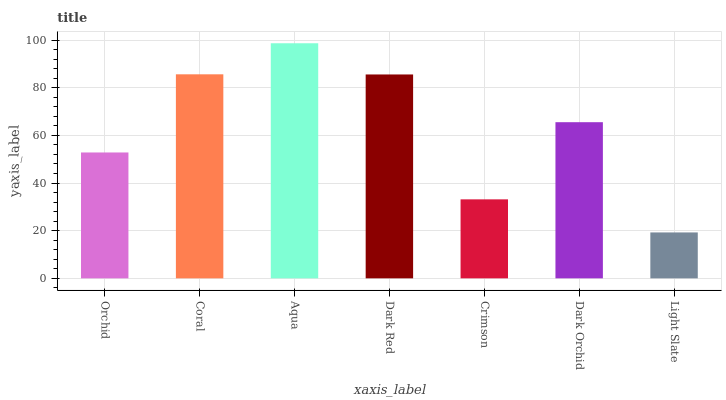Is Light Slate the minimum?
Answer yes or no. Yes. Is Aqua the maximum?
Answer yes or no. Yes. Is Coral the minimum?
Answer yes or no. No. Is Coral the maximum?
Answer yes or no. No. Is Coral greater than Orchid?
Answer yes or no. Yes. Is Orchid less than Coral?
Answer yes or no. Yes. Is Orchid greater than Coral?
Answer yes or no. No. Is Coral less than Orchid?
Answer yes or no. No. Is Dark Orchid the high median?
Answer yes or no. Yes. Is Dark Orchid the low median?
Answer yes or no. Yes. Is Orchid the high median?
Answer yes or no. No. Is Aqua the low median?
Answer yes or no. No. 